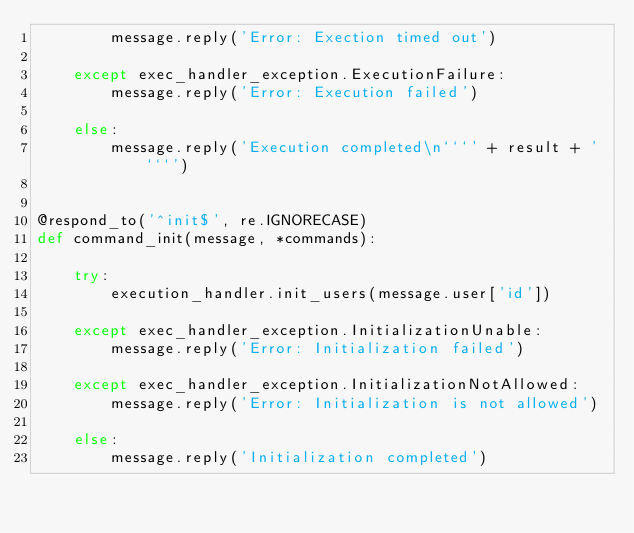<code> <loc_0><loc_0><loc_500><loc_500><_Python_>        message.reply('Error: Exection timed out')

    except exec_handler_exception.ExecutionFailure:
        message.reply('Error: Execution failed')

    else:
        message.reply('Execution completed\n```' + result + '```')


@respond_to('^init$', re.IGNORECASE)
def command_init(message, *commands):

    try:
        execution_handler.init_users(message.user['id'])

    except exec_handler_exception.InitializationUnable:
        message.reply('Error: Initialization failed')

    except exec_handler_exception.InitializationNotAllowed:
        message.reply('Error: Initialization is not allowed')

    else:
        message.reply('Initialization completed')
</code> 